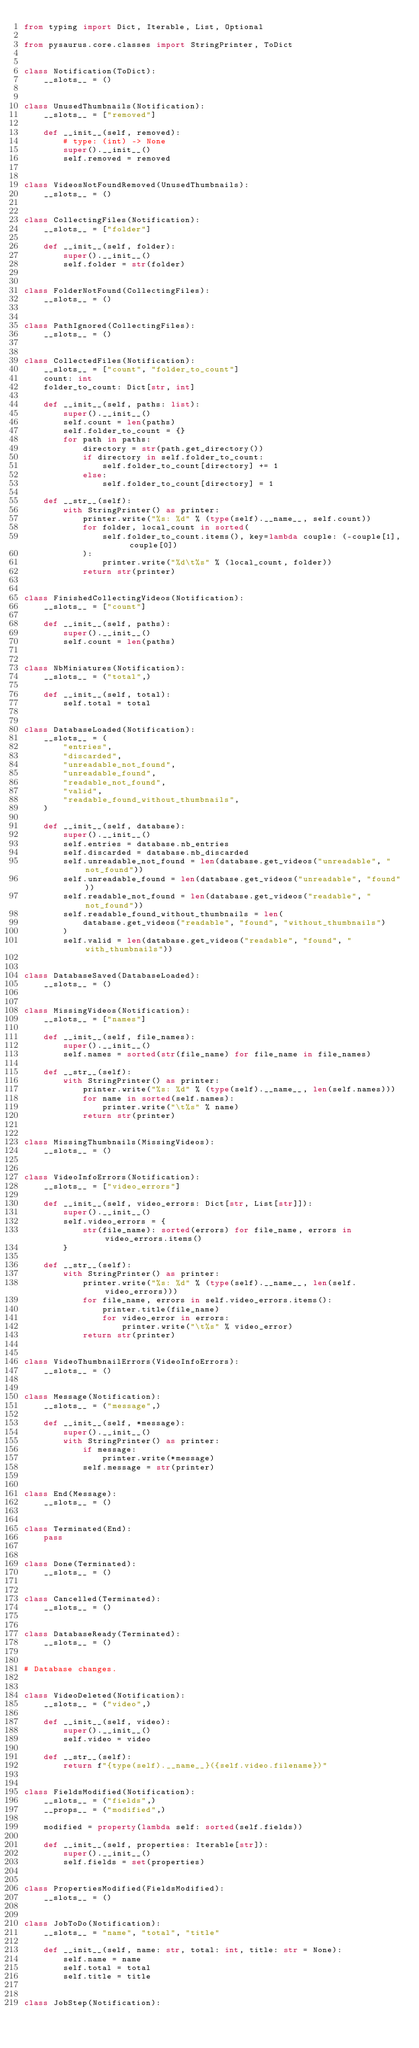Convert code to text. <code><loc_0><loc_0><loc_500><loc_500><_Python_>from typing import Dict, Iterable, List, Optional

from pysaurus.core.classes import StringPrinter, ToDict


class Notification(ToDict):
    __slots__ = ()


class UnusedThumbnails(Notification):
    __slots__ = ["removed"]

    def __init__(self, removed):
        # type: (int) -> None
        super().__init__()
        self.removed = removed


class VideosNotFoundRemoved(UnusedThumbnails):
    __slots__ = ()


class CollectingFiles(Notification):
    __slots__ = ["folder"]

    def __init__(self, folder):
        super().__init__()
        self.folder = str(folder)


class FolderNotFound(CollectingFiles):
    __slots__ = ()


class PathIgnored(CollectingFiles):
    __slots__ = ()


class CollectedFiles(Notification):
    __slots__ = ["count", "folder_to_count"]
    count: int
    folder_to_count: Dict[str, int]

    def __init__(self, paths: list):
        super().__init__()
        self.count = len(paths)
        self.folder_to_count = {}
        for path in paths:
            directory = str(path.get_directory())
            if directory in self.folder_to_count:
                self.folder_to_count[directory] += 1
            else:
                self.folder_to_count[directory] = 1

    def __str__(self):
        with StringPrinter() as printer:
            printer.write("%s: %d" % (type(self).__name__, self.count))
            for folder, local_count in sorted(
                self.folder_to_count.items(), key=lambda couple: (-couple[1], couple[0])
            ):
                printer.write("%d\t%s" % (local_count, folder))
            return str(printer)


class FinishedCollectingVideos(Notification):
    __slots__ = ["count"]

    def __init__(self, paths):
        super().__init__()
        self.count = len(paths)


class NbMiniatures(Notification):
    __slots__ = ("total",)

    def __init__(self, total):
        self.total = total


class DatabaseLoaded(Notification):
    __slots__ = (
        "entries",
        "discarded",
        "unreadable_not_found",
        "unreadable_found",
        "readable_not_found",
        "valid",
        "readable_found_without_thumbnails",
    )

    def __init__(self, database):
        super().__init__()
        self.entries = database.nb_entries
        self.discarded = database.nb_discarded
        self.unreadable_not_found = len(database.get_videos("unreadable", "not_found"))
        self.unreadable_found = len(database.get_videos("unreadable", "found"))
        self.readable_not_found = len(database.get_videos("readable", "not_found"))
        self.readable_found_without_thumbnails = len(
            database.get_videos("readable", "found", "without_thumbnails")
        )
        self.valid = len(database.get_videos("readable", "found", "with_thumbnails"))


class DatabaseSaved(DatabaseLoaded):
    __slots__ = ()


class MissingVideos(Notification):
    __slots__ = ["names"]

    def __init__(self, file_names):
        super().__init__()
        self.names = sorted(str(file_name) for file_name in file_names)

    def __str__(self):
        with StringPrinter() as printer:
            printer.write("%s: %d" % (type(self).__name__, len(self.names)))
            for name in sorted(self.names):
                printer.write("\t%s" % name)
            return str(printer)


class MissingThumbnails(MissingVideos):
    __slots__ = ()


class VideoInfoErrors(Notification):
    __slots__ = ["video_errors"]

    def __init__(self, video_errors: Dict[str, List[str]]):
        super().__init__()
        self.video_errors = {
            str(file_name): sorted(errors) for file_name, errors in video_errors.items()
        }

    def __str__(self):
        with StringPrinter() as printer:
            printer.write("%s: %d" % (type(self).__name__, len(self.video_errors)))
            for file_name, errors in self.video_errors.items():
                printer.title(file_name)
                for video_error in errors:
                    printer.write("\t%s" % video_error)
            return str(printer)


class VideoThumbnailErrors(VideoInfoErrors):
    __slots__ = ()


class Message(Notification):
    __slots__ = ("message",)

    def __init__(self, *message):
        super().__init__()
        with StringPrinter() as printer:
            if message:
                printer.write(*message)
            self.message = str(printer)


class End(Message):
    __slots__ = ()


class Terminated(End):
    pass


class Done(Terminated):
    __slots__ = ()


class Cancelled(Terminated):
    __slots__ = ()


class DatabaseReady(Terminated):
    __slots__ = ()


# Database changes.


class VideoDeleted(Notification):
    __slots__ = ("video",)

    def __init__(self, video):
        super().__init__()
        self.video = video

    def __str__(self):
        return f"{type(self).__name__}({self.video.filename})"


class FieldsModified(Notification):
    __slots__ = ("fields",)
    __props__ = ("modified",)

    modified = property(lambda self: sorted(self.fields))

    def __init__(self, properties: Iterable[str]):
        super().__init__()
        self.fields = set(properties)


class PropertiesModified(FieldsModified):
    __slots__ = ()


class JobToDo(Notification):
    __slots__ = "name", "total", "title"

    def __init__(self, name: str, total: int, title: str = None):
        self.name = name
        self.total = total
        self.title = title


class JobStep(Notification):</code> 